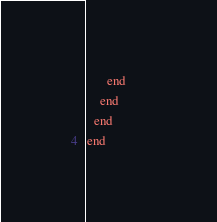Convert code to text. <code><loc_0><loc_0><loc_500><loc_500><_Ruby_>      end      
    end
  end
end</code> 